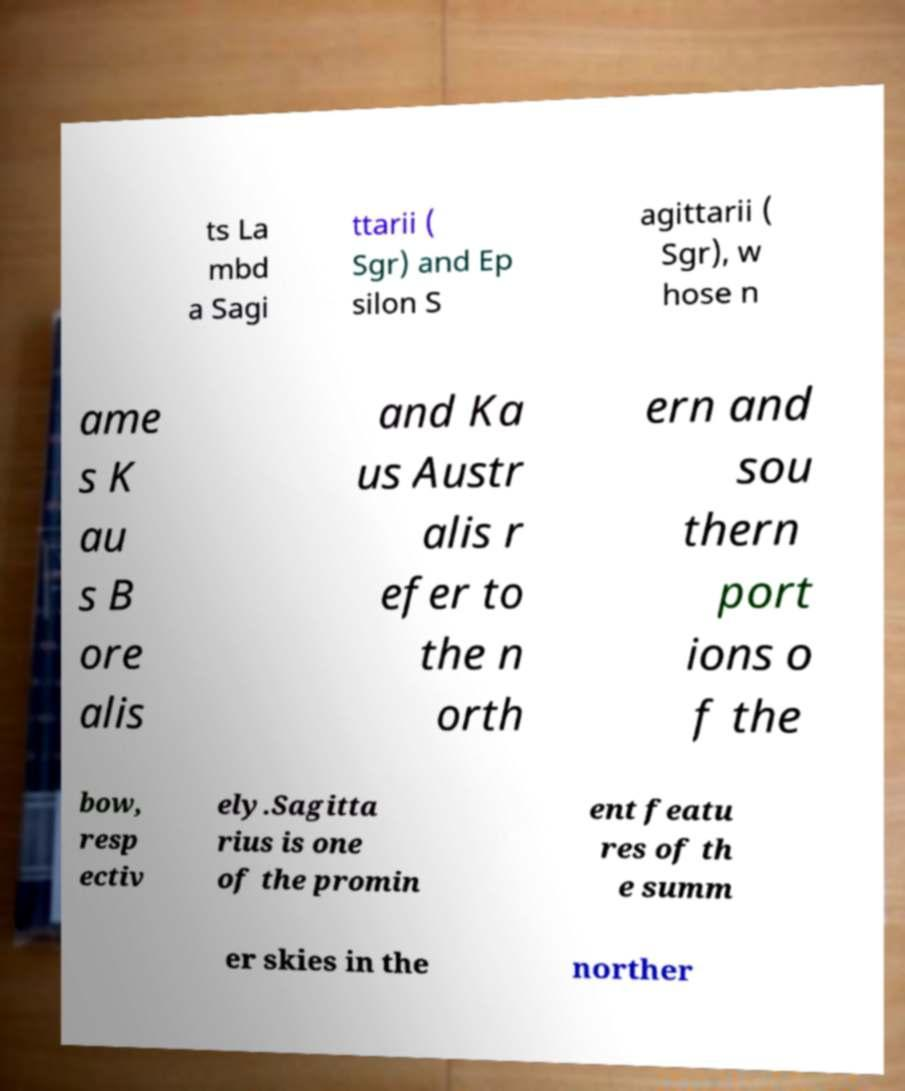Please read and relay the text visible in this image. What does it say? ts La mbd a Sagi ttarii ( Sgr) and Ep silon S agittarii ( Sgr), w hose n ame s K au s B ore alis and Ka us Austr alis r efer to the n orth ern and sou thern port ions o f the bow, resp ectiv ely.Sagitta rius is one of the promin ent featu res of th e summ er skies in the norther 